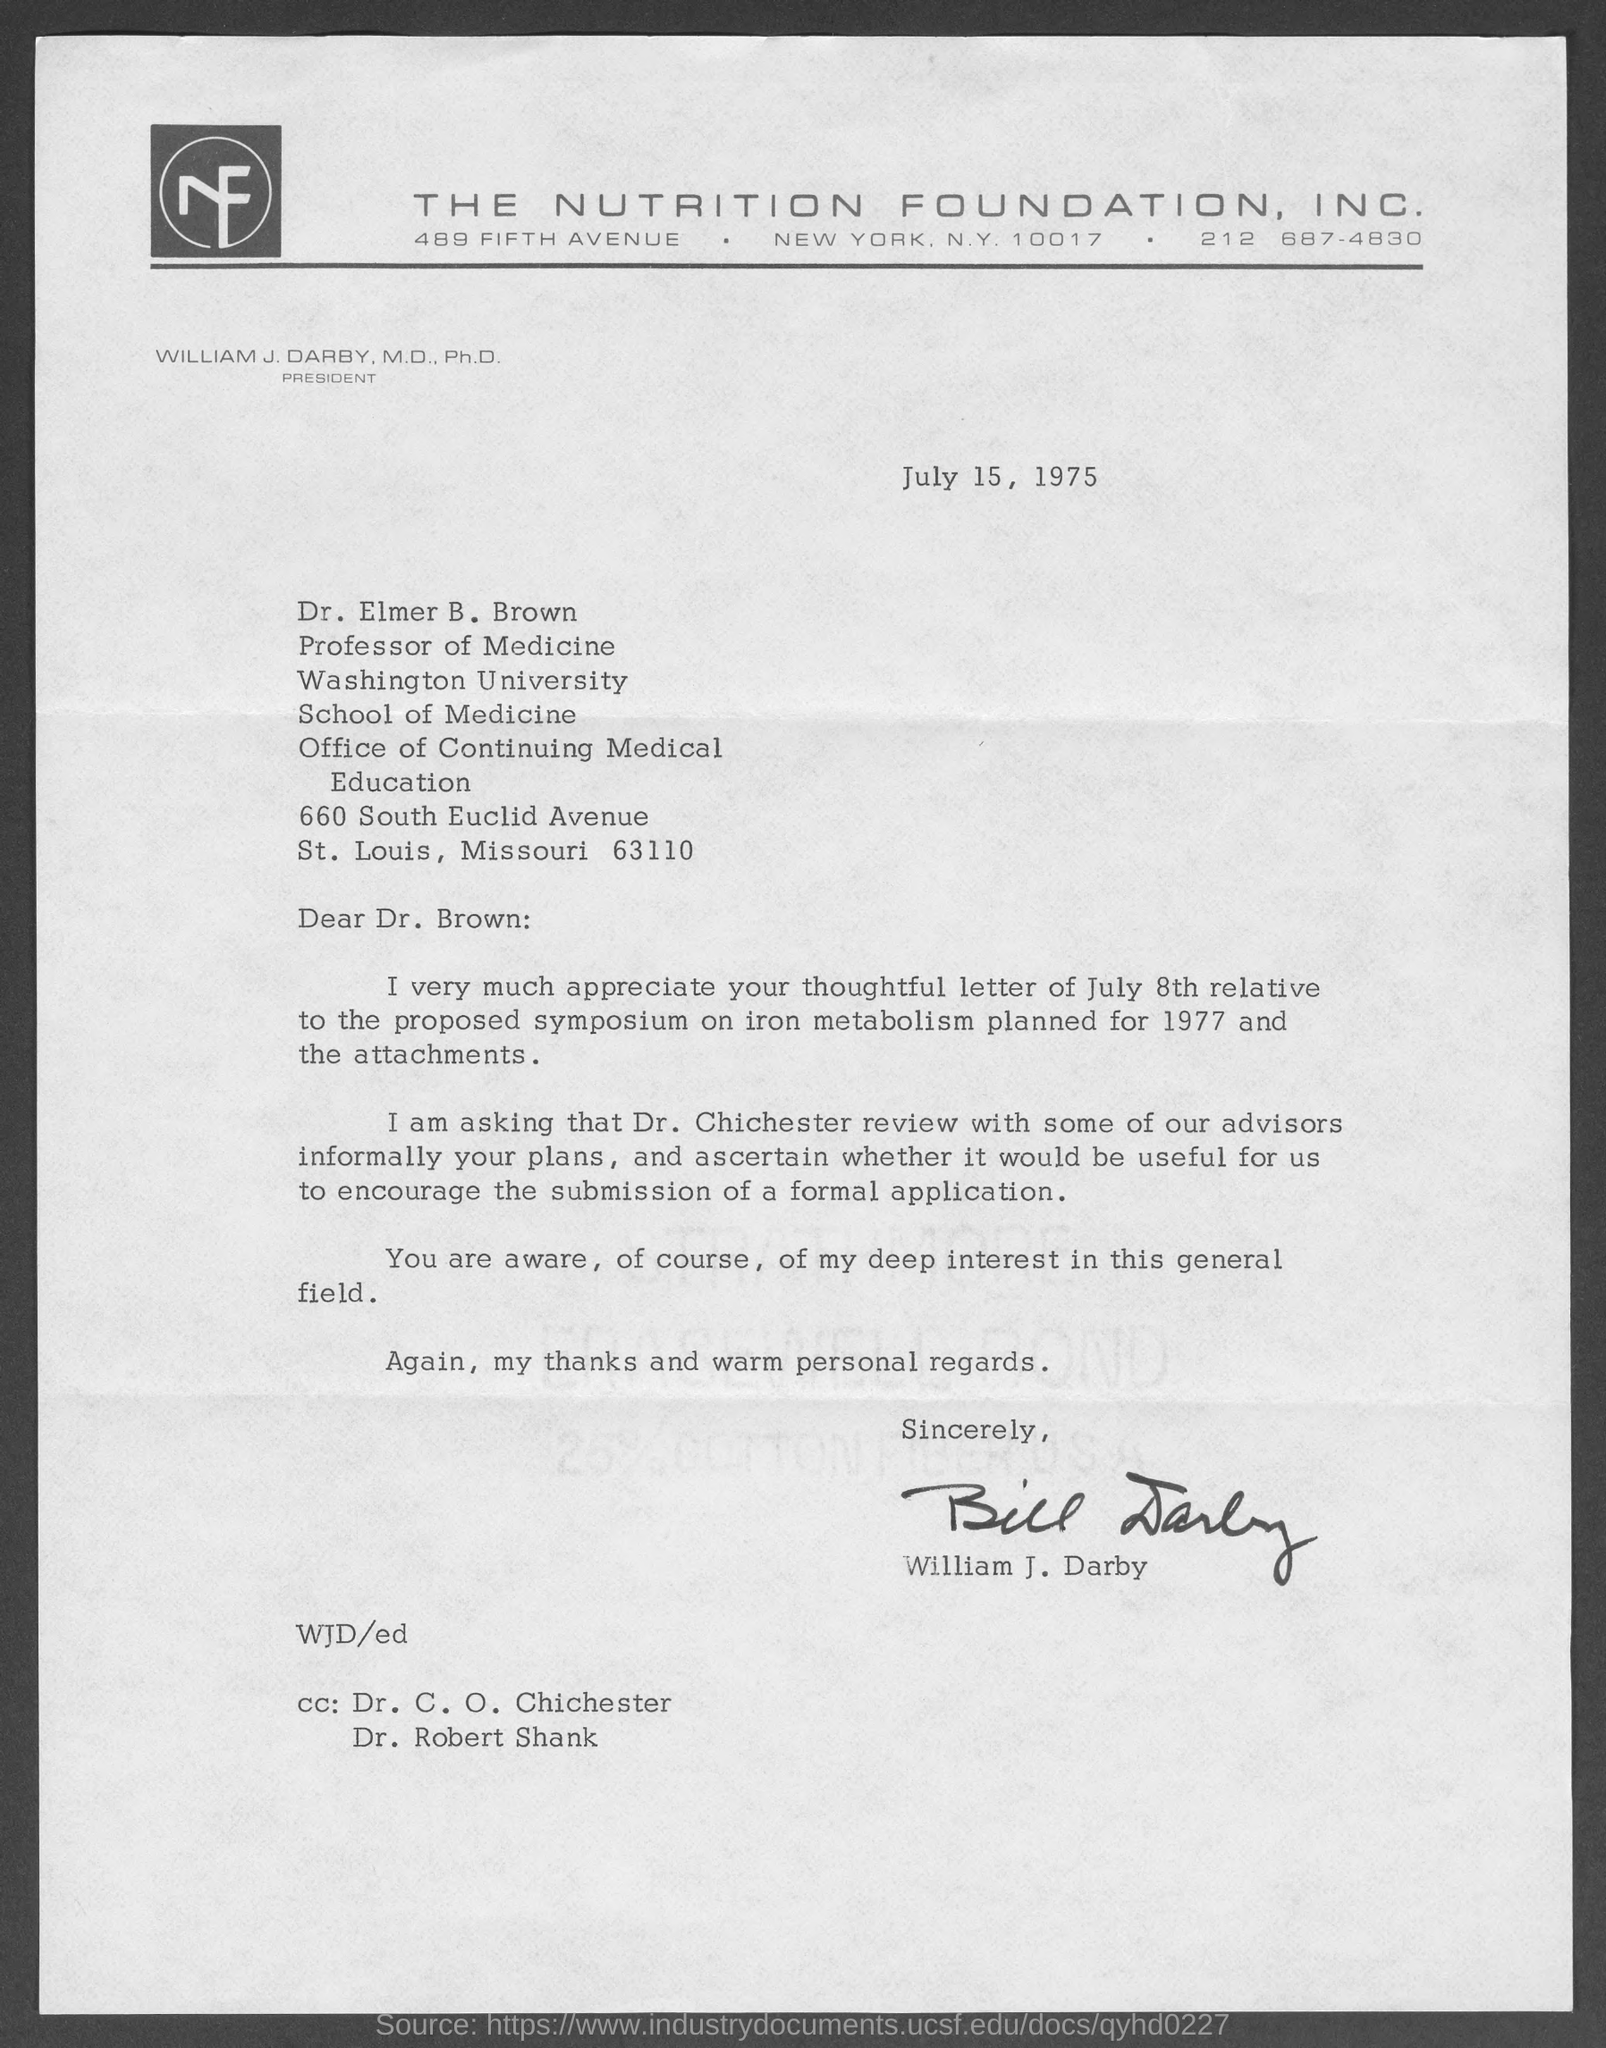Give some essential details in this illustration. William J. Darby has signed the letter. It has been decided to have Dr. Chichester review Dr. Brown's plans with some of the advisors informally. The nutrition foundation, Inc. is mentioned at the top of the page. The letter is addressed to Dr. Brown. The proposed symposium will focus on the topic of iron metabolism. 